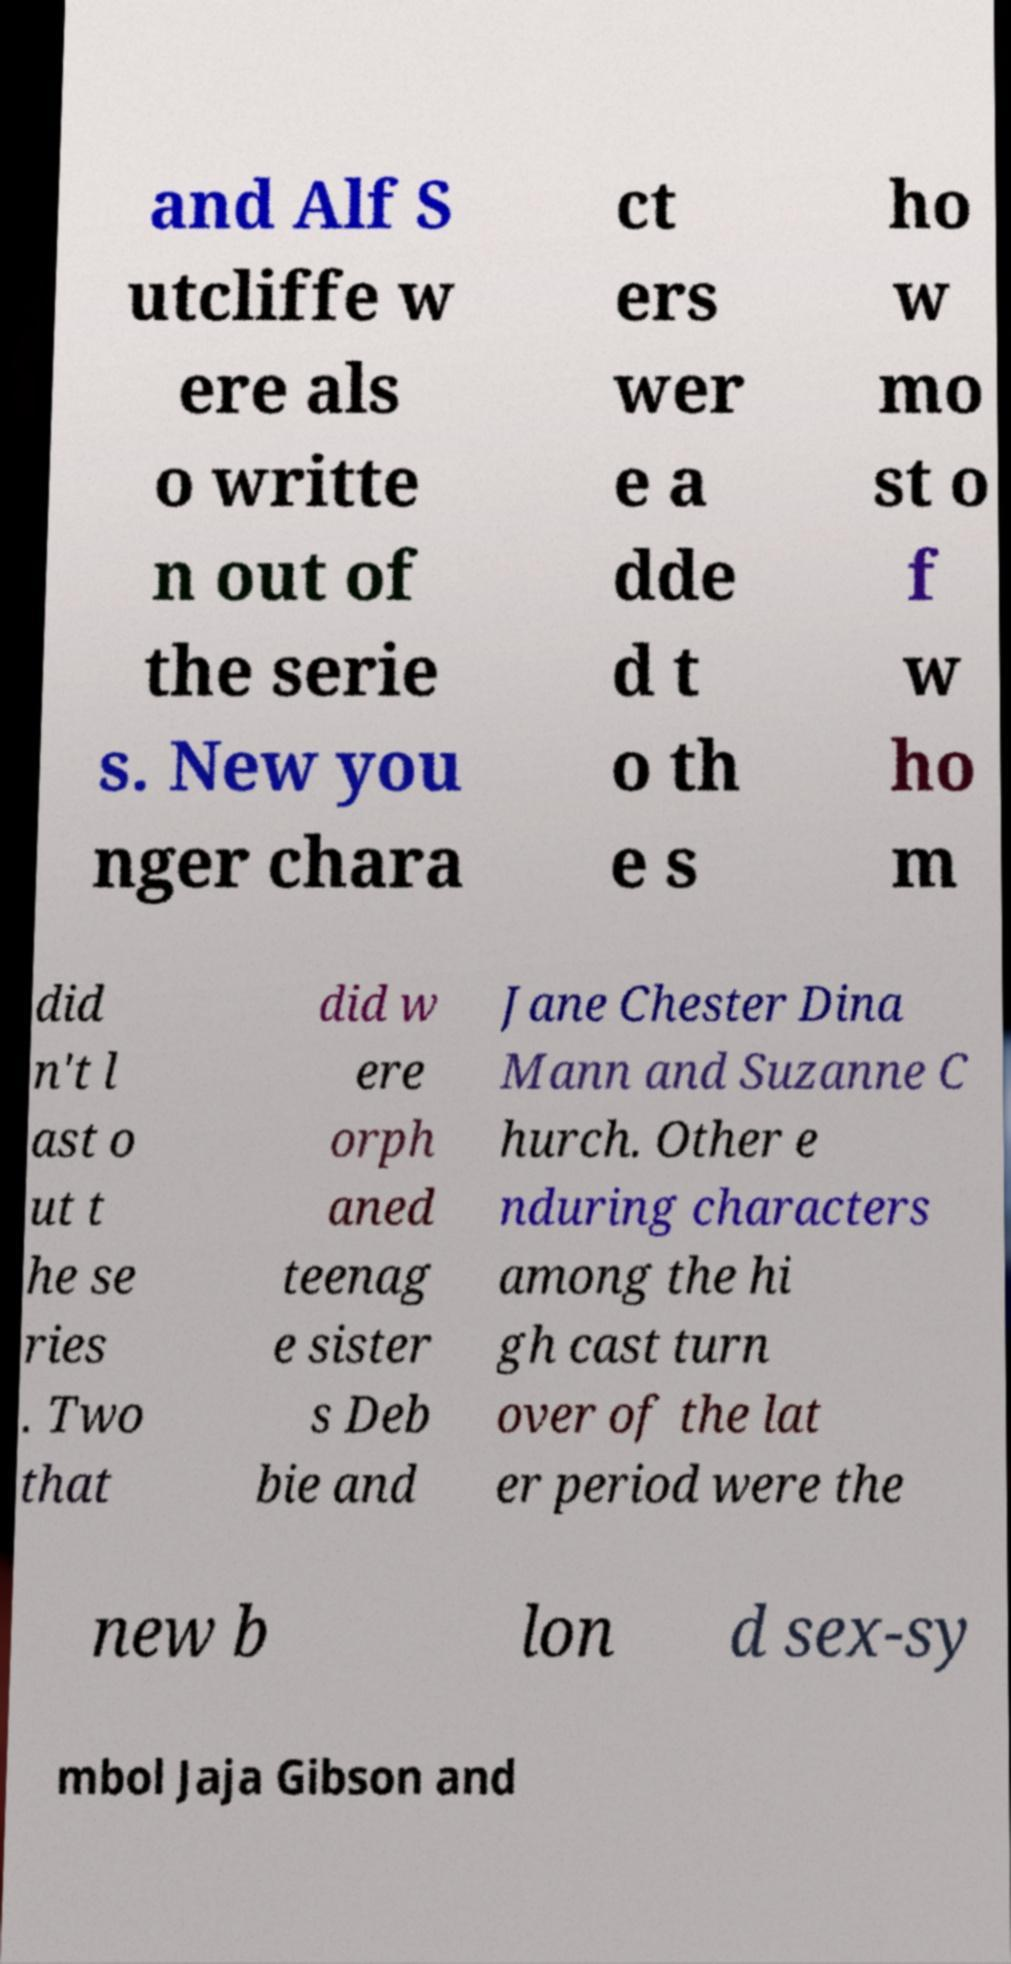Can you accurately transcribe the text from the provided image for me? and Alf S utcliffe w ere als o writte n out of the serie s. New you nger chara ct ers wer e a dde d t o th e s ho w mo st o f w ho m did n't l ast o ut t he se ries . Two that did w ere orph aned teenag e sister s Deb bie and Jane Chester Dina Mann and Suzanne C hurch. Other e nduring characters among the hi gh cast turn over of the lat er period were the new b lon d sex-sy mbol Jaja Gibson and 